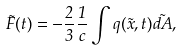Convert formula to latex. <formula><loc_0><loc_0><loc_500><loc_500>\vec { F } ( t ) = - \frac { 2 } { 3 } \frac { 1 } { c } \int q ( \vec { x } , t ) \vec { d A } ,</formula> 